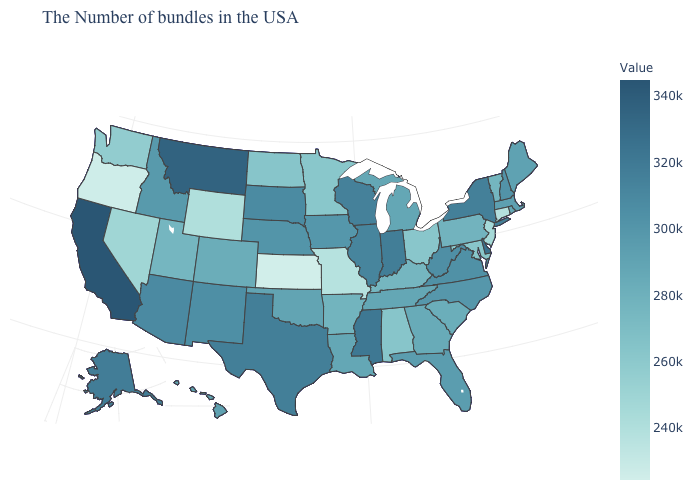Among the states that border North Carolina , does Virginia have the highest value?
Quick response, please. Yes. Among the states that border Florida , which have the lowest value?
Quick response, please. Alabama. Does Mississippi have a lower value than Montana?
Concise answer only. Yes. 